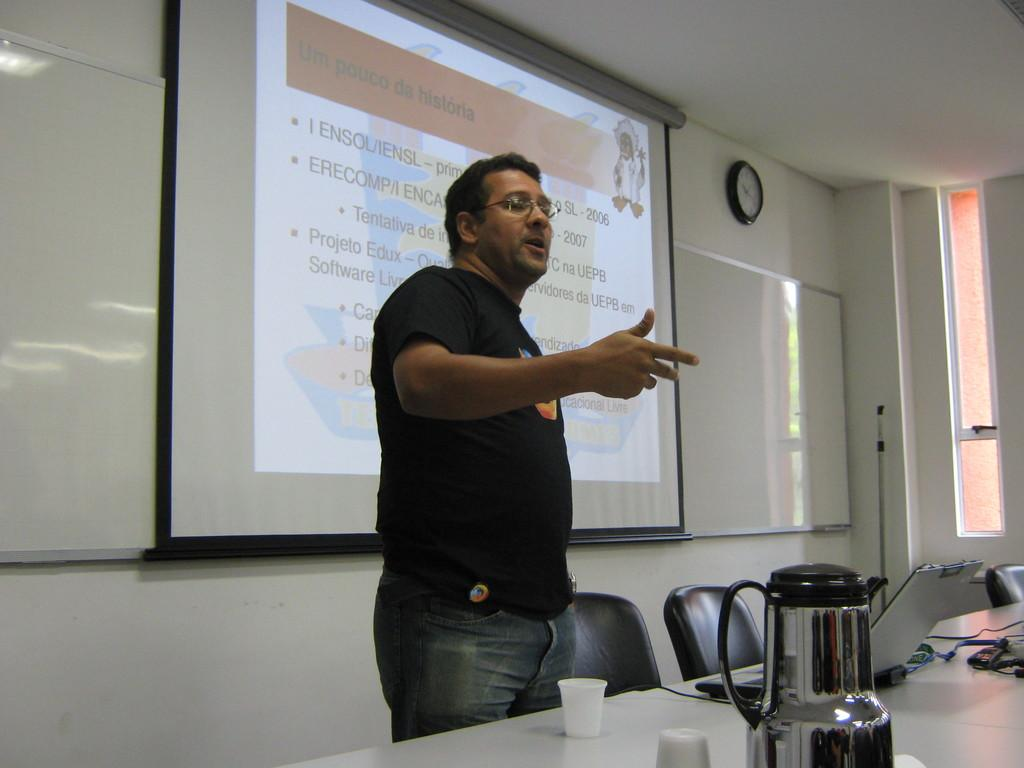<image>
Give a short and clear explanation of the subsequent image. A man giving a presentation in front of a slide titled 'Um pouco da historia' 